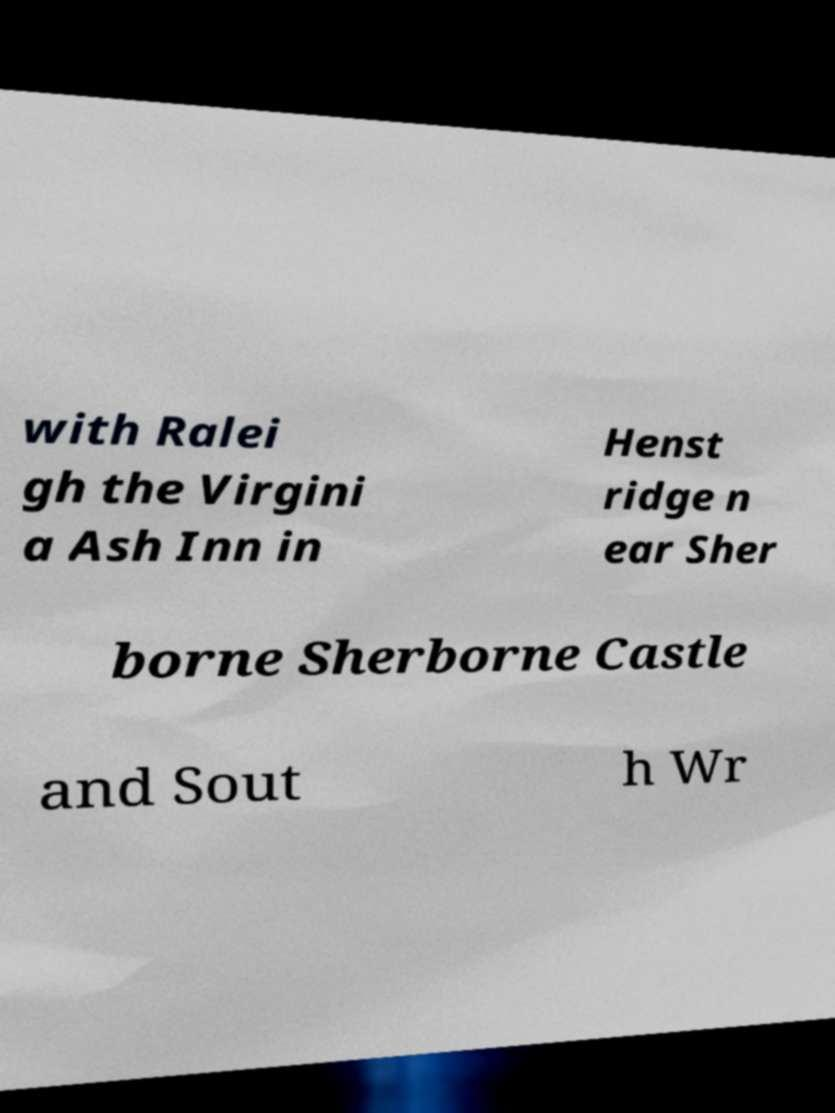Could you extract and type out the text from this image? with Ralei gh the Virgini a Ash Inn in Henst ridge n ear Sher borne Sherborne Castle and Sout h Wr 